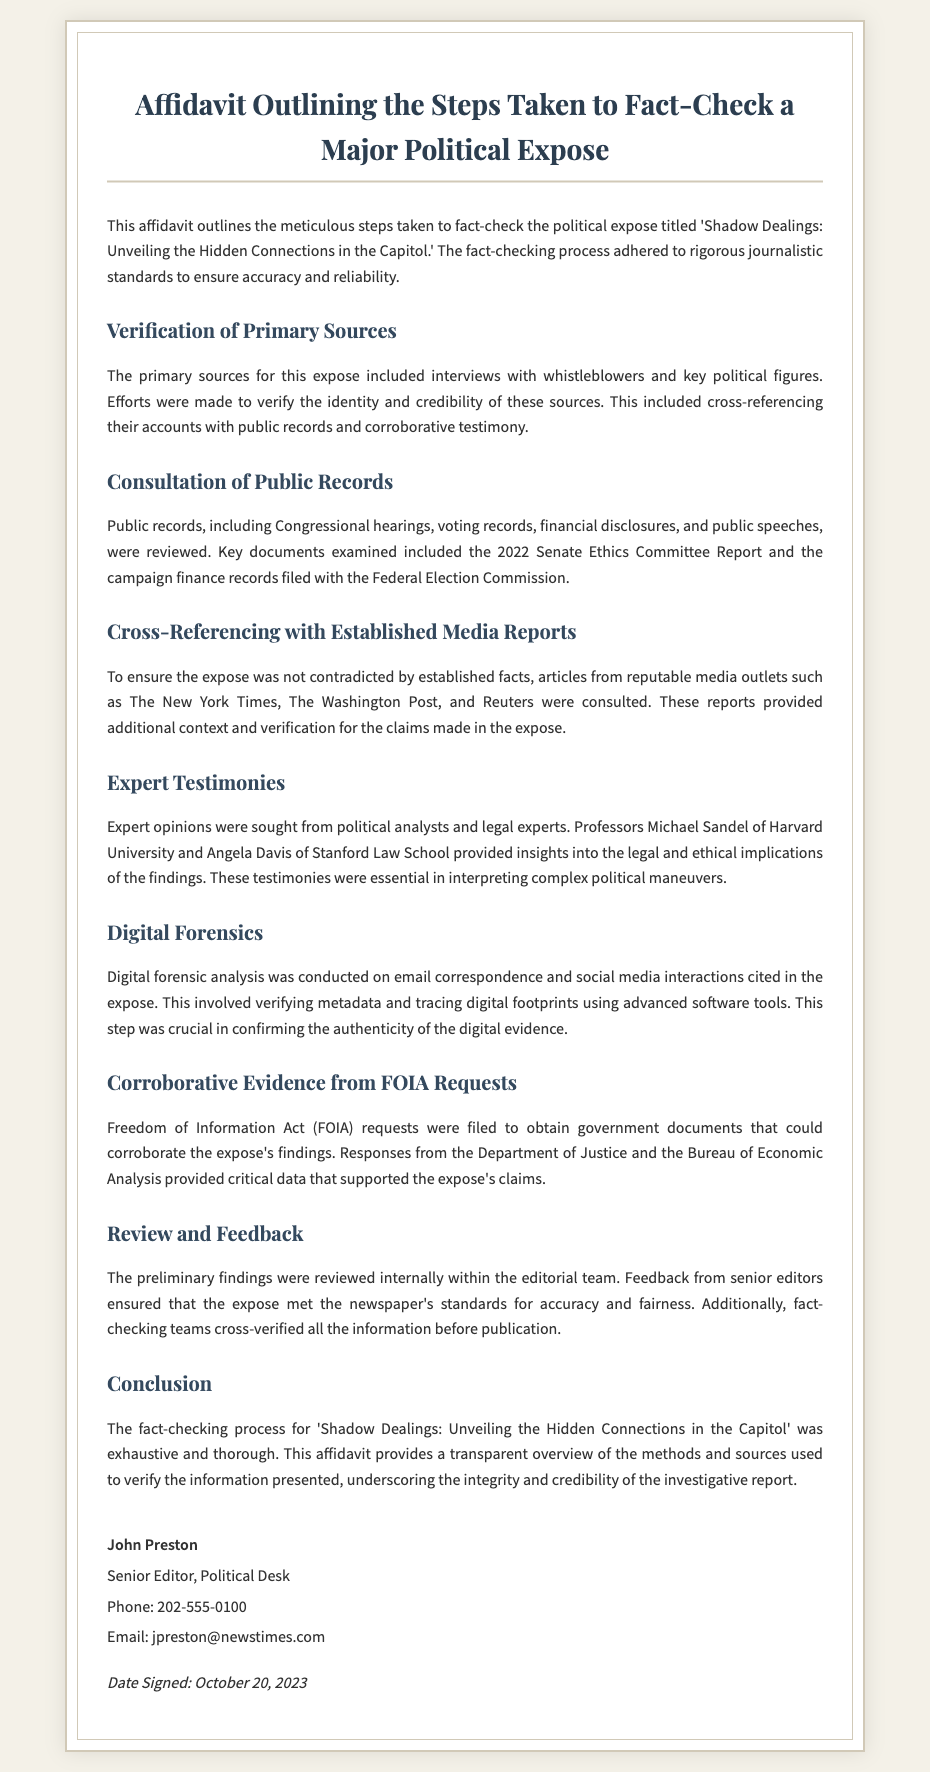What is the title of the political expose? The title mentioned in the affidavit for the political expose is 'Shadow Dealings: Unveiling the Hidden Connections in the Capitol.'
Answer: 'Shadow Dealings: Unveiling the Hidden Connections in the Capitol.' Who are the two experts mentioned in the affidavit? The affidavit lists Professors Michael Sandel and Angela Davis as the experts consulted for insights.
Answer: Michael Sandel and Angela Davis What type of records were consulted during the fact-checking process? The affidavit states that public records including Congressional hearings, voting records, financial disclosures, and public speeches were reviewed.
Answer: Public records How many steps are outlined in the fact-checking process? The document outlines several distinct steps, each detailed in its own section related to verification and consultation.
Answer: Several distinct steps What is the date signed on the affidavit? The affidavit includes a specific date signed, which appears at the bottom of the document.
Answer: October 20, 2023 What organization provided FOIA responses mentioned in the document? The affidavit notes that responses were obtained from the Department of Justice and the Bureau of Economic Analysis.
Answer: Department of Justice and Bureau of Economic Analysis What was the purpose of interviewing whistleblowers and key political figures? The primary purpose was to verify the identity and credibility of the sources for the expose's claims.
Answer: Verify identity and credibility Which media outlets were consulted for cross-referencing? The affidavit specifically lists The New York Times, The Washington Post, and Reuters as consulted media outlets.
Answer: The New York Times, The Washington Post, and Reuters What did the internal review process ensure about the expose? The internal review process ensured that the expose met the newspaper's standards for accuracy and fairness prior to publication.
Answer: Accuracy and fairness 